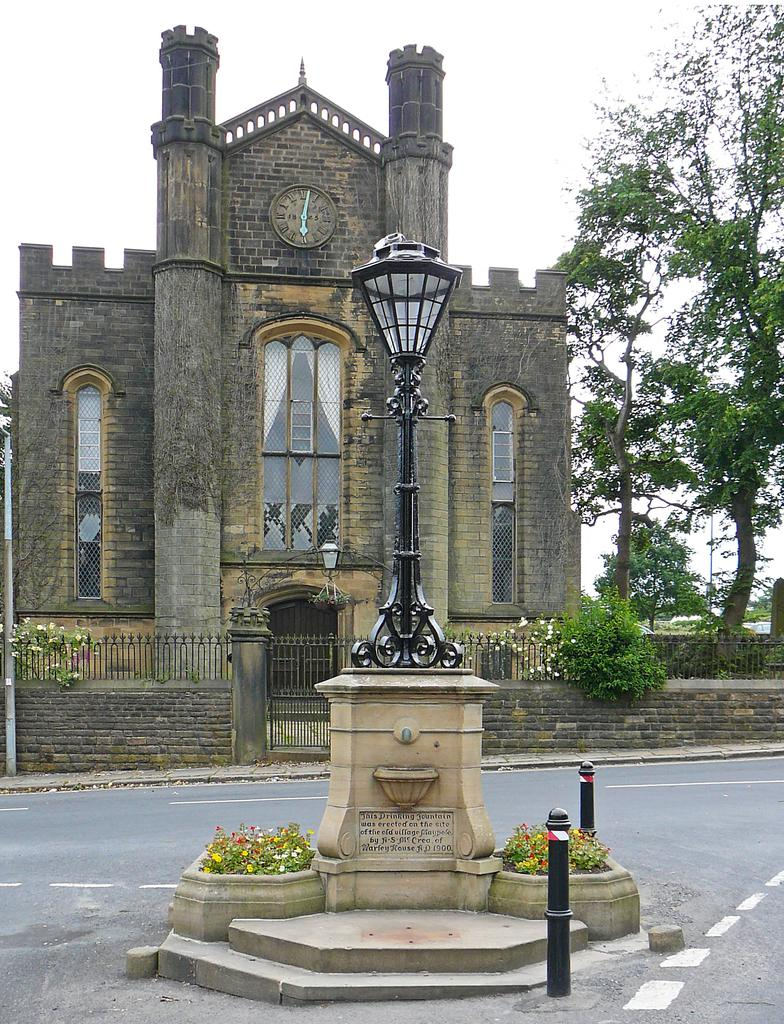What is the main object in the center of the image? There is a black color lamp post in the center of the image. What type of building can be seen in the background? There is a brown color clock tower building in the background. What kind of vegetation is on the right side of the image? There are trees on the right side of the image. Can you tell me how many insects are crawling on the lamp post in the image? There are no insects visible on the lamp post in the image. What type of bike can be seen leaning against the clock tower building? There is no bike present in the image; it only features a lamp post and a clock tower building. 